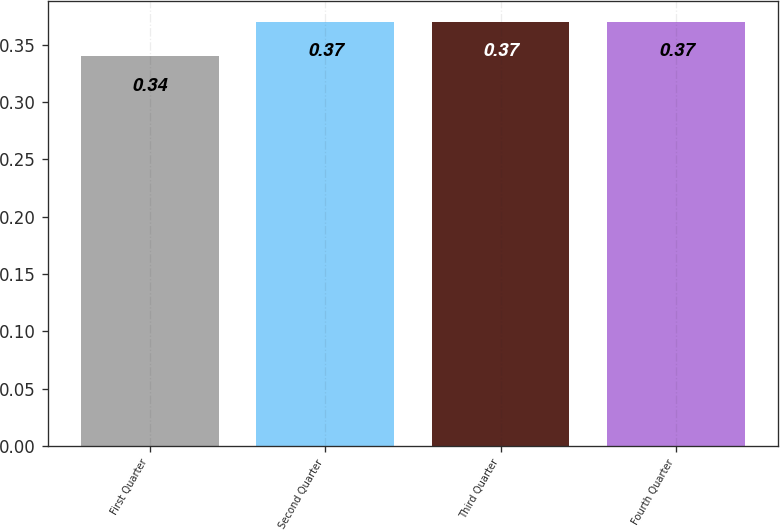Convert chart. <chart><loc_0><loc_0><loc_500><loc_500><bar_chart><fcel>First Quarter<fcel>Second Quarter<fcel>Third Quarter<fcel>Fourth Quarter<nl><fcel>0.34<fcel>0.37<fcel>0.37<fcel>0.37<nl></chart> 